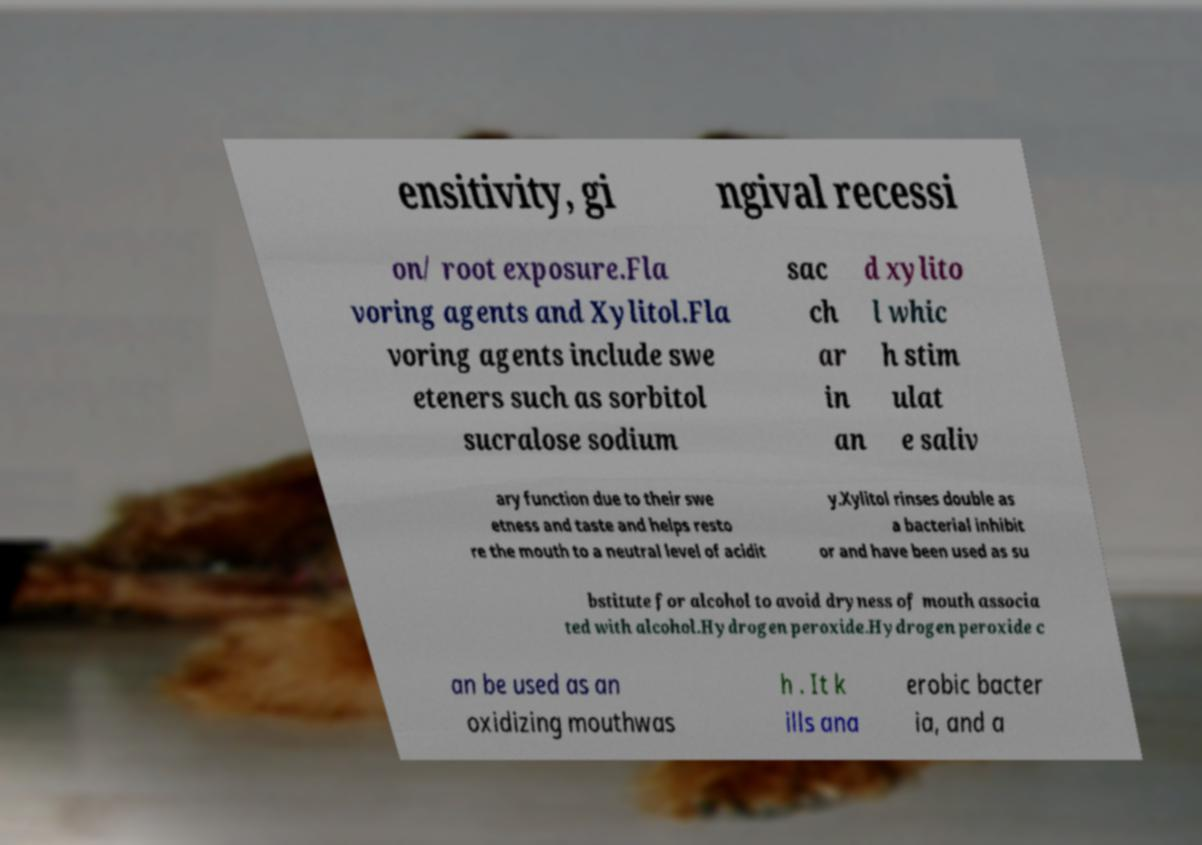What messages or text are displayed in this image? I need them in a readable, typed format. ensitivity, gi ngival recessi on/ root exposure.Fla voring agents and Xylitol.Fla voring agents include swe eteners such as sorbitol sucralose sodium sac ch ar in an d xylito l whic h stim ulat e saliv ary function due to their swe etness and taste and helps resto re the mouth to a neutral level of acidit y.Xylitol rinses double as a bacterial inhibit or and have been used as su bstitute for alcohol to avoid dryness of mouth associa ted with alcohol.Hydrogen peroxide.Hydrogen peroxide c an be used as an oxidizing mouthwas h . It k ills ana erobic bacter ia, and a 